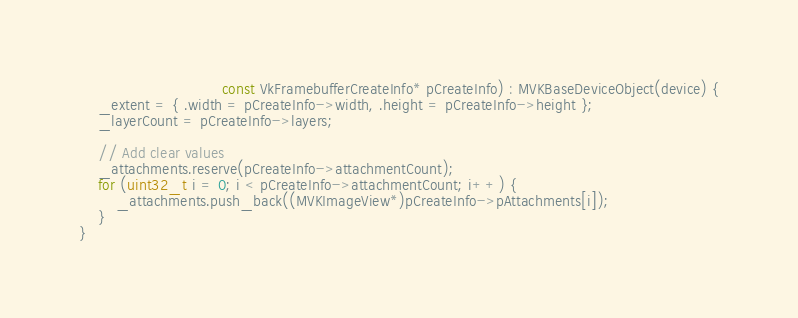Convert code to text. <code><loc_0><loc_0><loc_500><loc_500><_ObjectiveC_>							   const VkFramebufferCreateInfo* pCreateInfo) : MVKBaseDeviceObject(device) {
    _extent = { .width = pCreateInfo->width, .height = pCreateInfo->height };
	_layerCount = pCreateInfo->layers;

	// Add clear values
	_attachments.reserve(pCreateInfo->attachmentCount);
	for (uint32_t i = 0; i < pCreateInfo->attachmentCount; i++) {
		_attachments.push_back((MVKImageView*)pCreateInfo->pAttachments[i]);
	}
}

</code> 